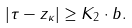<formula> <loc_0><loc_0><loc_500><loc_500>| \tau - z _ { \kappa } | \geq K _ { 2 } \cdot b .</formula> 